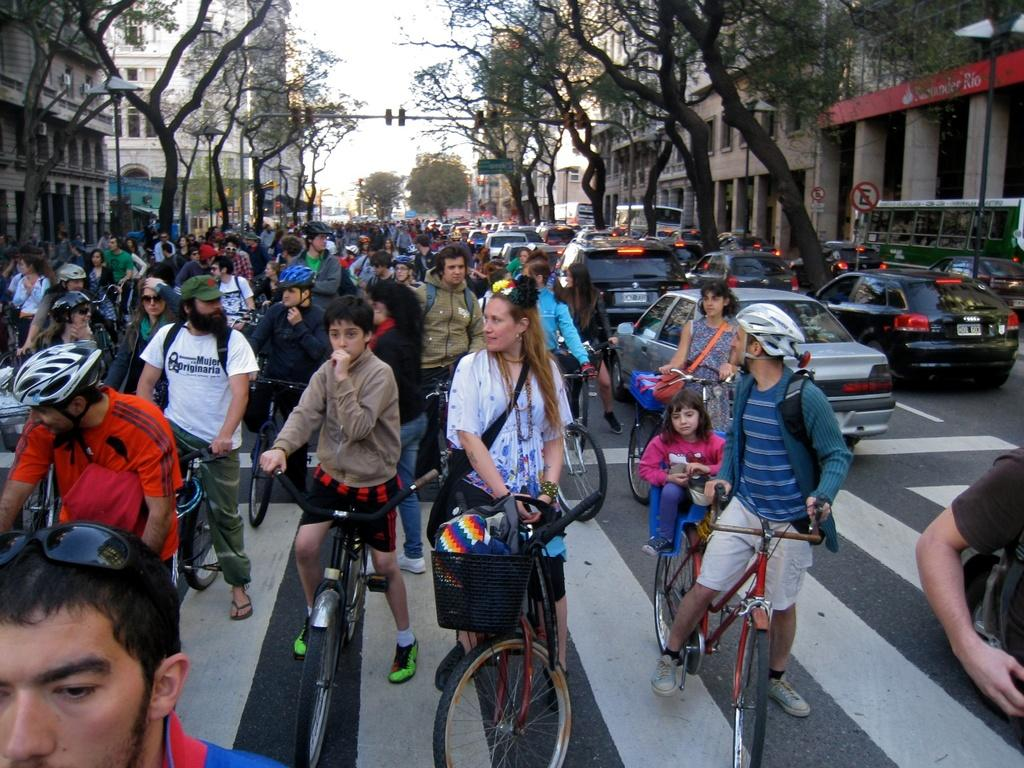What is happening in the image involving people? There is a group of people in the image, and they are standing with bicycles. What else can be seen on the road in the image? There are cars on the road in the image. What type of vegetation is visible in the image? There are trees to the side of the image. What type of structure is present in the image? There is a building in the image. What is visible in the background of the image? The sky is visible in the background of the image. What type of banana is being smashed by the group of people in the image? There is no banana present in the image, and the group of people are standing with bicycles, not smashing anything. What is the group of people feeling shame about in the image? There is no indication of shame or any negative emotion in the image; the group of people are simply standing with bicycles. 